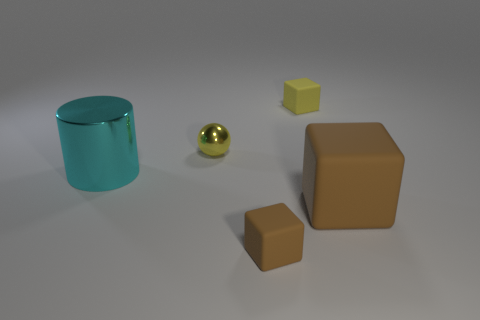How many objects are both on the right side of the big cyan metallic thing and on the left side of the big brown block?
Your answer should be very brief. 3. Are there more tiny yellow metallic objects in front of the large brown matte cube than large blue matte cubes?
Offer a terse response. No. What number of cyan metallic cylinders are the same size as the yellow metal ball?
Offer a terse response. 0. There is a thing that is the same color as the large rubber cube; what is its size?
Your answer should be compact. Small. How many small objects are either yellow shiny things or rubber objects?
Your response must be concise. 3. What number of large cyan cylinders are there?
Provide a succinct answer. 1. Are there the same number of tiny shiny balls behind the small shiny sphere and yellow shiny spheres right of the tiny yellow cube?
Provide a short and direct response. Yes. There is a sphere; are there any tiny spheres behind it?
Offer a very short reply. No. The small matte cube to the left of the small yellow matte block is what color?
Provide a short and direct response. Brown. There is a yellow thing on the left side of the small rubber thing that is in front of the big cyan cylinder; what is its material?
Offer a very short reply. Metal. 